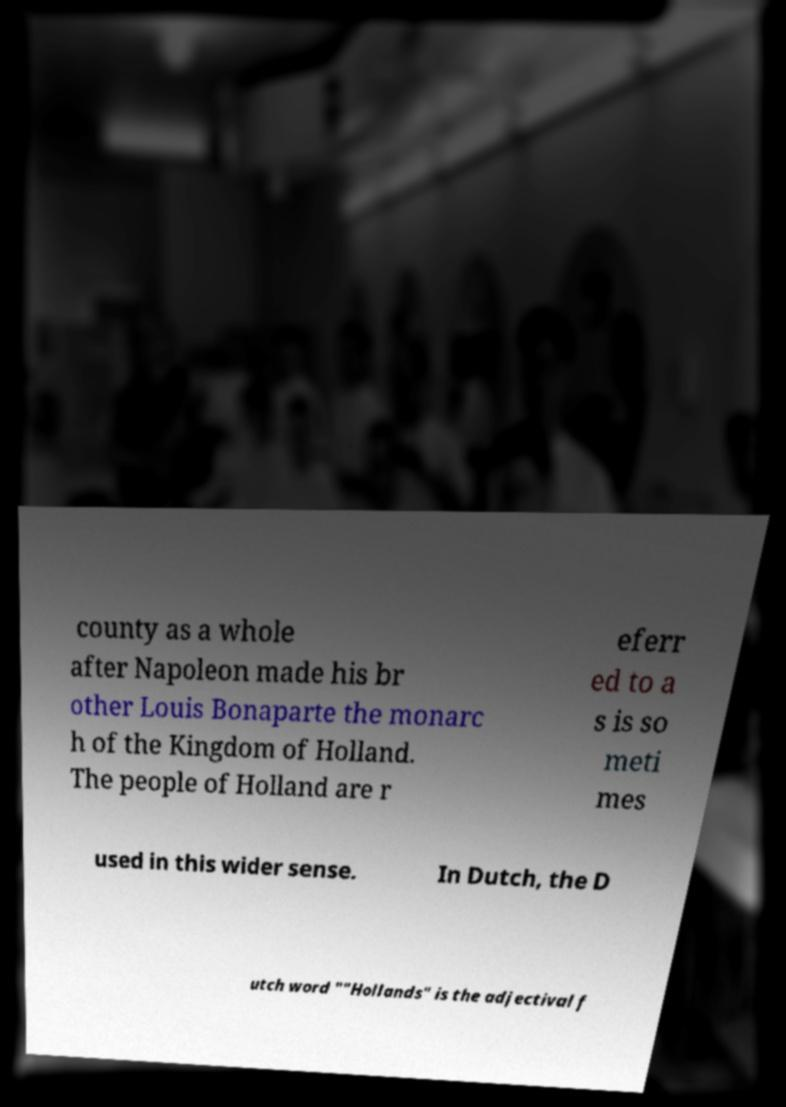Could you extract and type out the text from this image? county as a whole after Napoleon made his br other Louis Bonaparte the monarc h of the Kingdom of Holland. The people of Holland are r eferr ed to a s is so meti mes used in this wider sense. In Dutch, the D utch word ""Hollands" is the adjectival f 